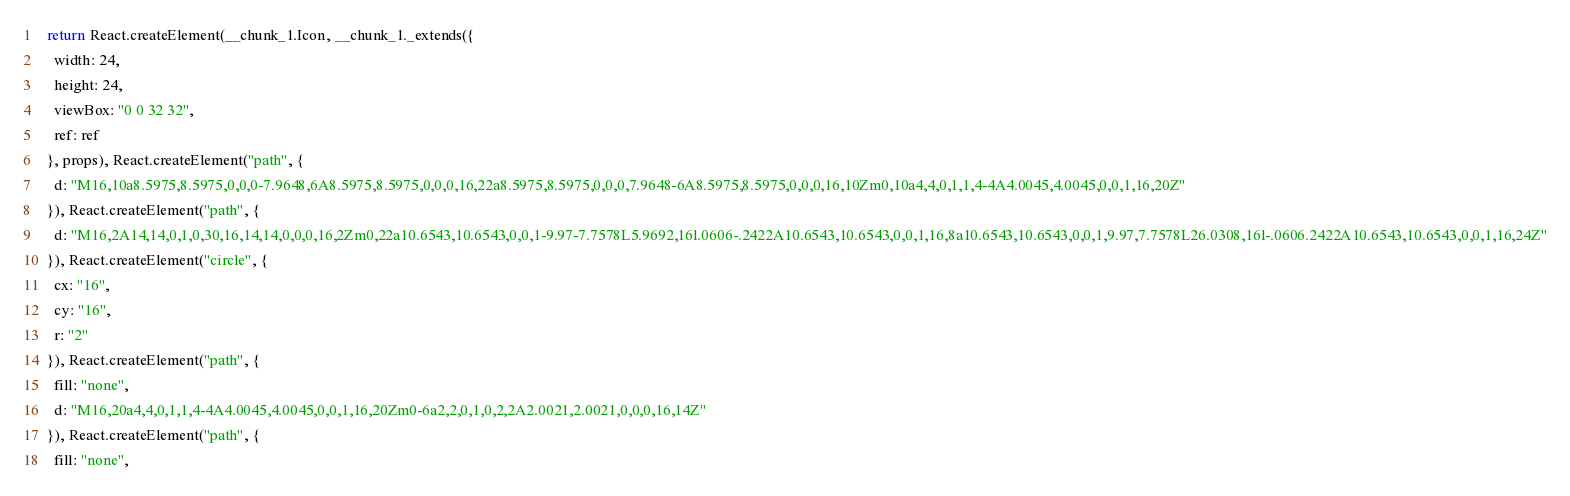<code> <loc_0><loc_0><loc_500><loc_500><_JavaScript_>  return React.createElement(__chunk_1.Icon, __chunk_1._extends({
    width: 24,
    height: 24,
    viewBox: "0 0 32 32",
    ref: ref
  }, props), React.createElement("path", {
    d: "M16,10a8.5975,8.5975,0,0,0-7.9648,6A8.5975,8.5975,0,0,0,16,22a8.5975,8.5975,0,0,0,7.9648-6A8.5975,8.5975,0,0,0,16,10Zm0,10a4,4,0,1,1,4-4A4.0045,4.0045,0,0,1,16,20Z"
  }), React.createElement("path", {
    d: "M16,2A14,14,0,1,0,30,16,14,14,0,0,0,16,2Zm0,22a10.6543,10.6543,0,0,1-9.97-7.7578L5.9692,16l.0606-.2422A10.6543,10.6543,0,0,1,16,8a10.6543,10.6543,0,0,1,9.97,7.7578L26.0308,16l-.0606.2422A10.6543,10.6543,0,0,1,16,24Z"
  }), React.createElement("circle", {
    cx: "16",
    cy: "16",
    r: "2"
  }), React.createElement("path", {
    fill: "none",
    d: "M16,20a4,4,0,1,1,4-4A4.0045,4.0045,0,0,1,16,20Zm0-6a2,2,0,1,0,2,2A2.0021,2.0021,0,0,0,16,14Z"
  }), React.createElement("path", {
    fill: "none",</code> 